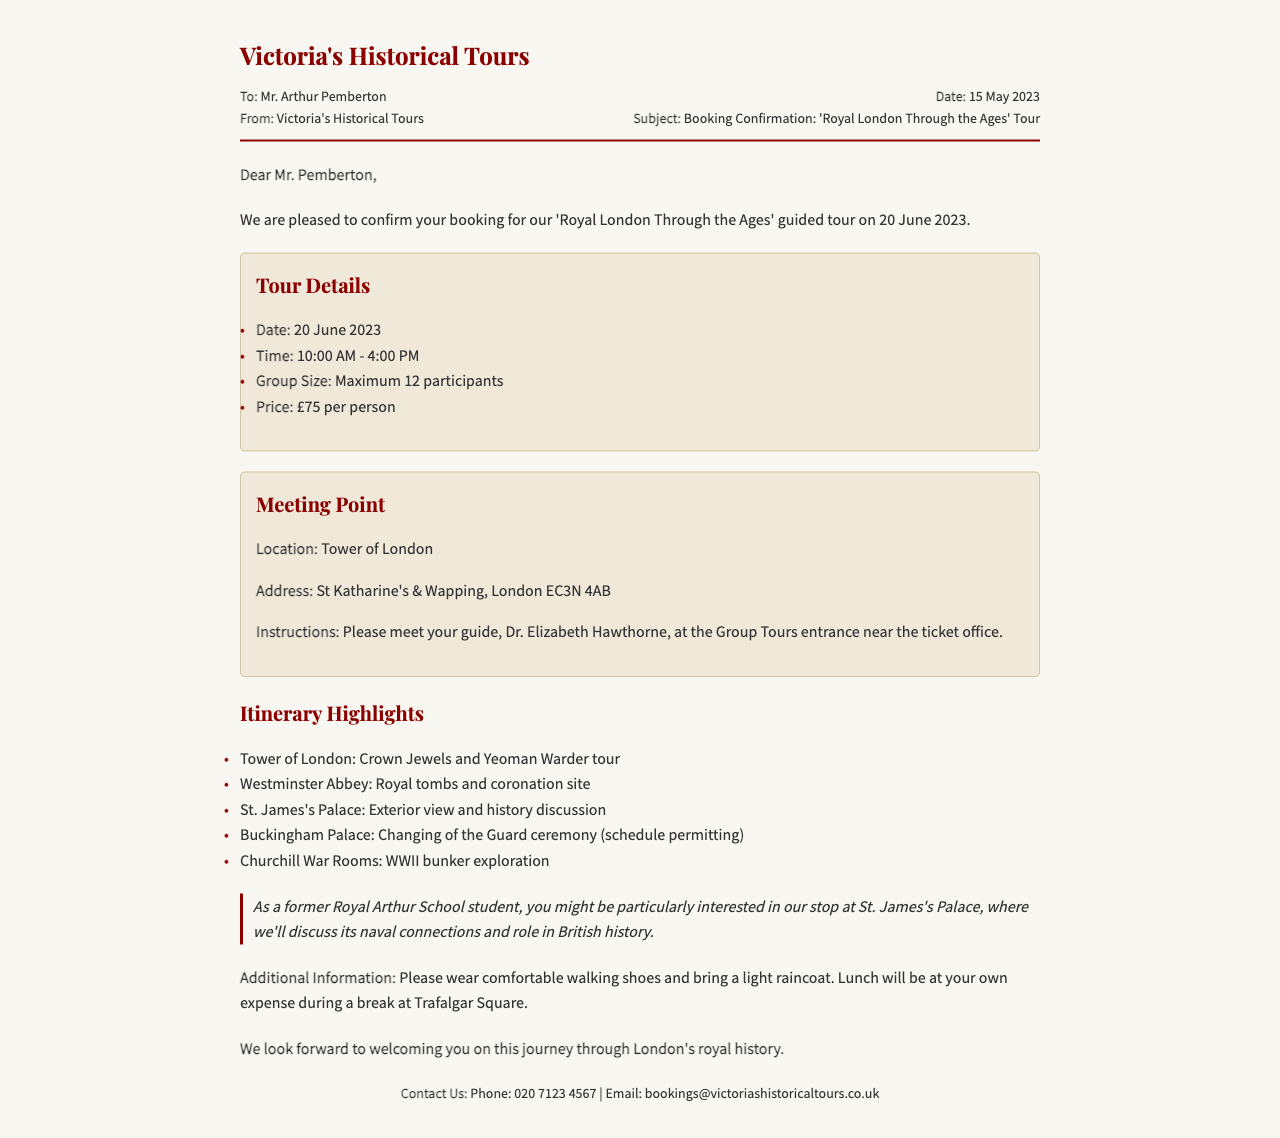what is the name of the tour? The name of the tour is mentioned in the subject line of the fax.
Answer: Royal London Through the Ages what is the date of the tour? The specific date is listed in the tour details section.
Answer: 20 June 2023 who is the tour guide? The guide's name is provided in the meeting point instructions.
Answer: Dr. Elizabeth Hawthorne how many participants are allowed in the group? The maximum group size is stated in the tour details section.
Answer: 12 participants what is the meeting location for the tour? The location is specified in the meeting point section of the document.
Answer: Tower of London what is the price per person for the tour? The price is outlined in the tour details section.
Answer: £75 which historical site is mentioned for discussion related to the Royal Arthur School? The site is highlighted in the special note that mentions the naval connections.
Answer: St. James's Palace what time does the tour start? The starting time is listed in the tour details section.
Answer: 10:00 AM what should participants wear for comfort? This information is provided in the additional information section.
Answer: Comfortable walking shoes 